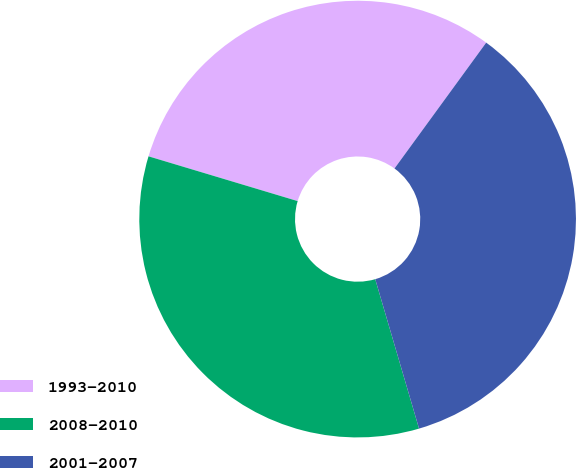Convert chart to OTSL. <chart><loc_0><loc_0><loc_500><loc_500><pie_chart><fcel>1993-2010<fcel>2008-2010<fcel>2001-2007<nl><fcel>30.38%<fcel>34.18%<fcel>35.44%<nl></chart> 